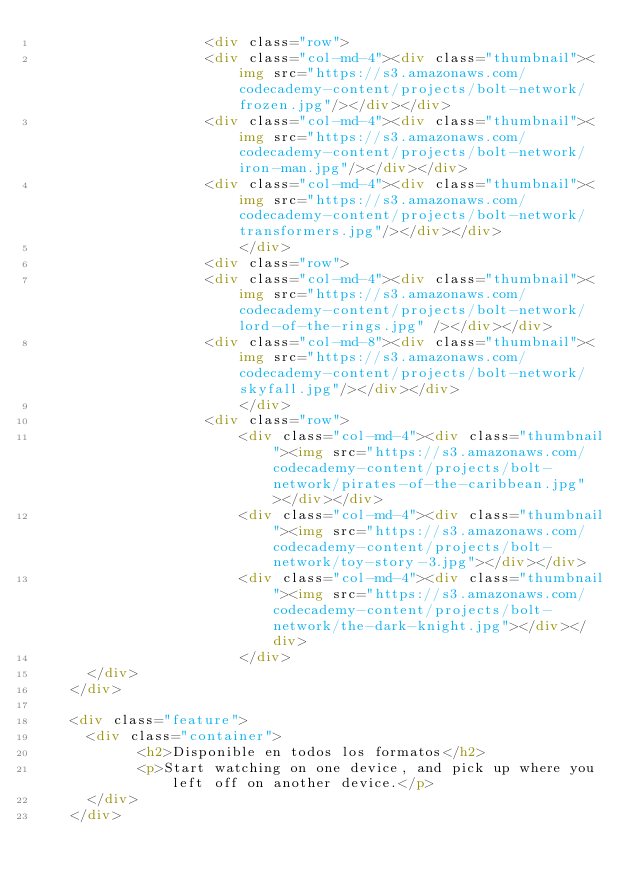Convert code to text. <code><loc_0><loc_0><loc_500><loc_500><_HTML_>                	<div class="row">
                    <div class="col-md-4"><div class="thumbnail"><img src="https://s3.amazonaws.com/codecademy-content/projects/bolt-network/frozen.jpg"/></div></div>
                    <div class="col-md-4"><div class="thumbnail"><img src="https://s3.amazonaws.com/codecademy-content/projects/bolt-network/iron-man.jpg"/></div></div>
                    <div class="col-md-4"><div class="thumbnail"><img src="https://s3.amazonaws.com/codecademy-content/projects/bolt-network/transformers.jpg"/></div></div>
        				</div>
                	<div class="row">
                    <div class="col-md-4"><div class="thumbnail"><img src="https://s3.amazonaws.com/codecademy-content/projects/bolt-network/lord-of-the-rings.jpg" /></div></div>
                    <div class="col-md-8"><div class="thumbnail"><img src="https://s3.amazonaws.com/codecademy-content/projects/bolt-network/skyfall.jpg"/></div></div>
        				</div>
                	<div class="row">
                    	<div class="col-md-4"><div class="thumbnail"><img src="https://s3.amazonaws.com/codecademy-content/projects/bolt-network/pirates-of-the-caribbean.jpg"></div></div>
                    	<div class="col-md-4"><div class="thumbnail"><img src="https://s3.amazonaws.com/codecademy-content/projects/bolt-network/toy-story-3.jpg"></div></div>
                    	<div class="col-md-4"><div class="thumbnail"><img src="https://s3.amazonaws.com/codecademy-content/projects/bolt-network/the-dark-knight.jpg"></div></div>
        				</div>
      </div>
    </div>

    <div class="feature">
      <div class="container">
        	<h2>Disponible en todos los formatos</h2>
        	<p>Start watching on one device, and pick up where you left off on another device.</p>
      </div>
    </div>
</code> 